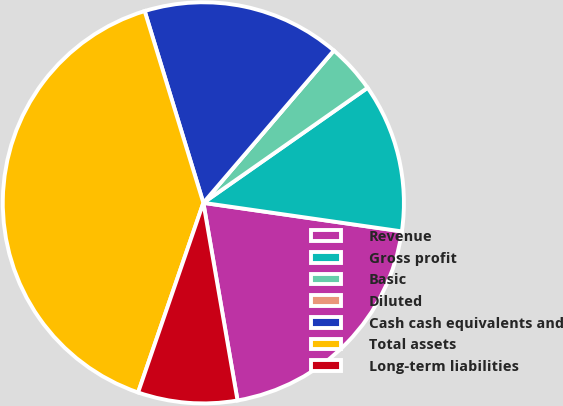<chart> <loc_0><loc_0><loc_500><loc_500><pie_chart><fcel>Revenue<fcel>Gross profit<fcel>Basic<fcel>Diluted<fcel>Cash cash equivalents and<fcel>Total assets<fcel>Long-term liabilities<nl><fcel>20.0%<fcel>12.0%<fcel>4.0%<fcel>0.0%<fcel>16.0%<fcel>40.0%<fcel>8.0%<nl></chart> 